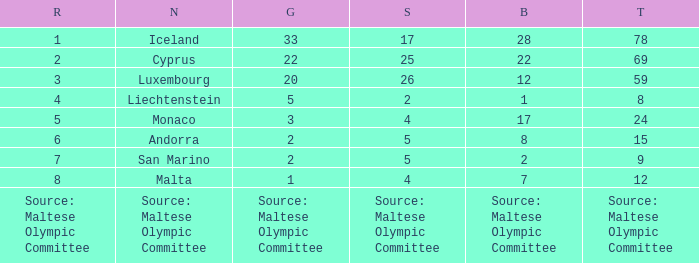What nation has 28 bronze medals? Iceland. 